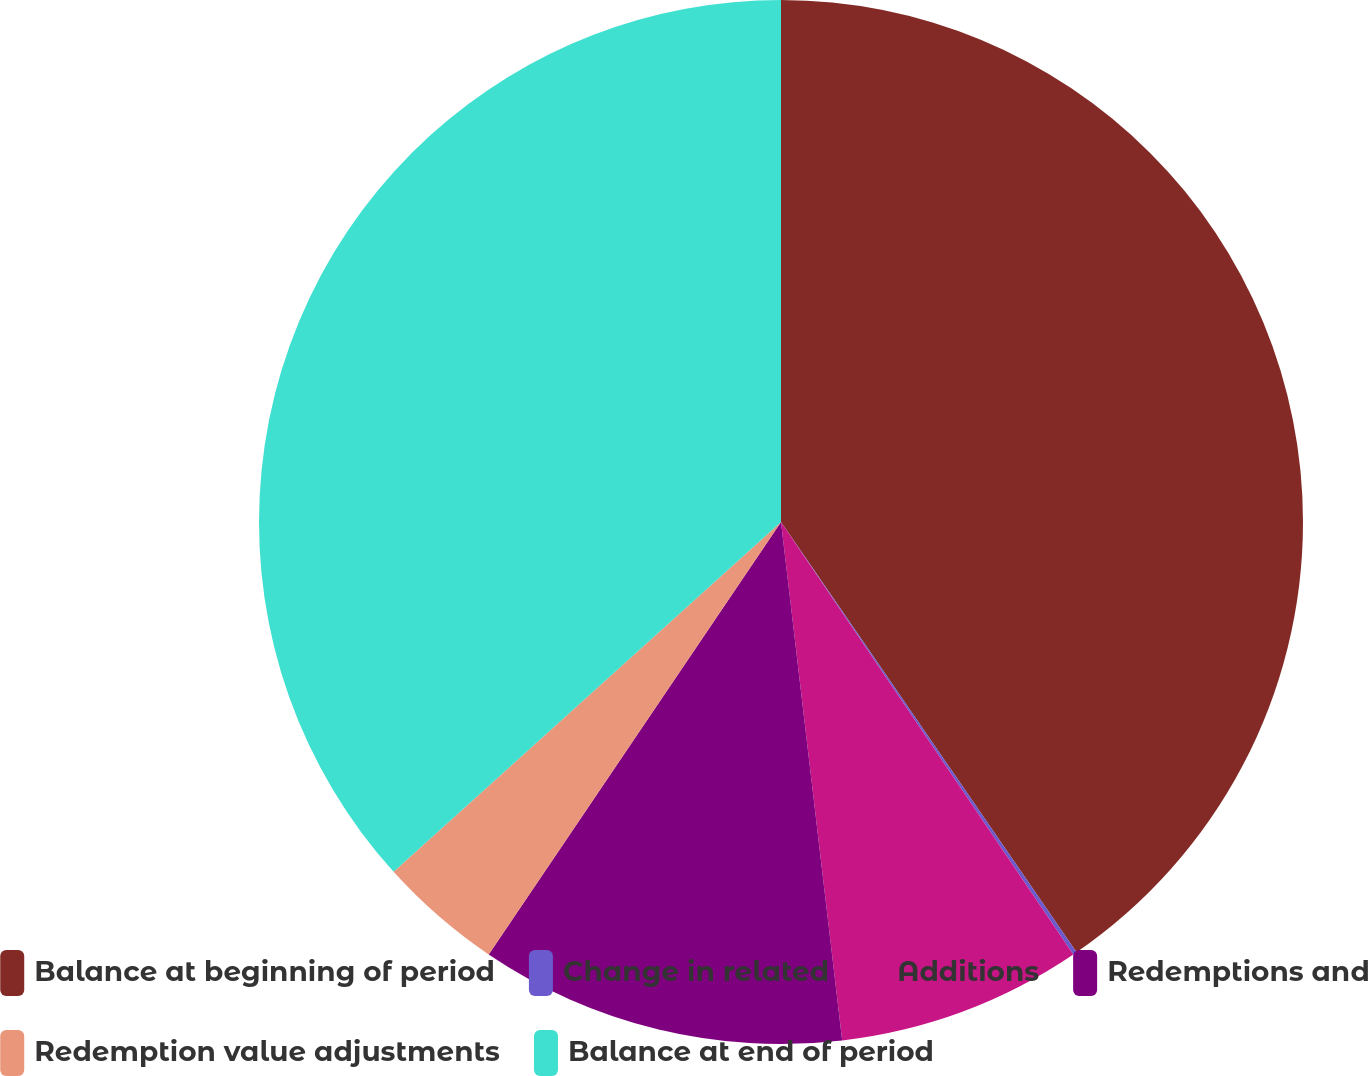<chart> <loc_0><loc_0><loc_500><loc_500><pie_chart><fcel>Balance at beginning of period<fcel>Change in related<fcel>Additions<fcel>Redemptions and<fcel>Redemption value adjustments<fcel>Balance at end of period<nl><fcel>40.42%<fcel>0.12%<fcel>7.59%<fcel>11.33%<fcel>3.85%<fcel>36.69%<nl></chart> 